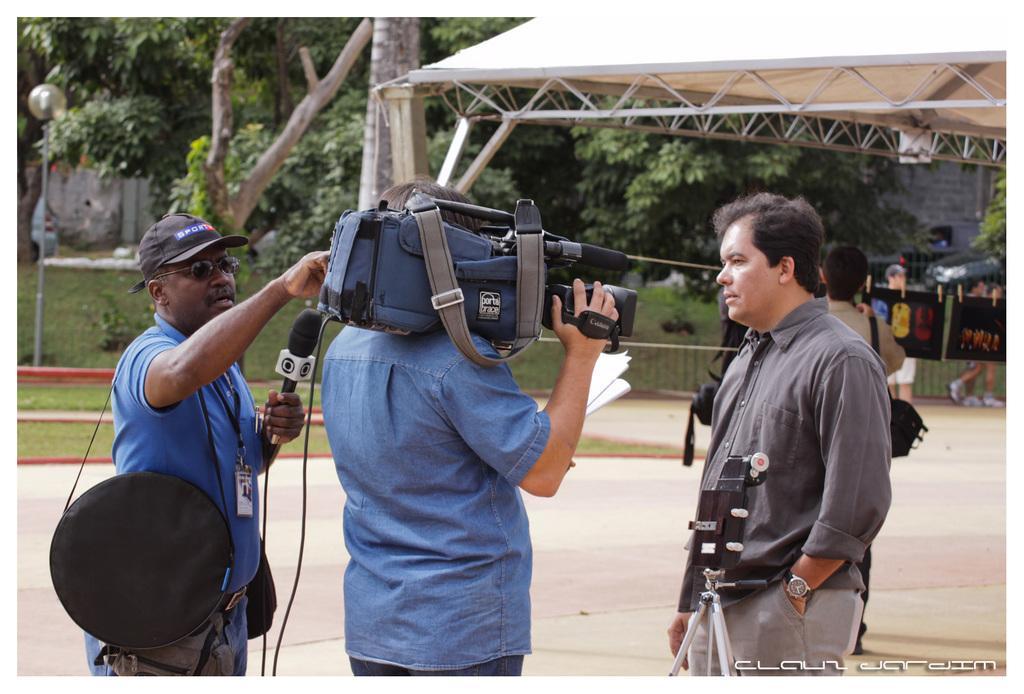How would you summarize this image in a sentence or two? In this image I can see few people where one is holding a mic and another one is holding a camera. In the background I can see number of trees and few more people. 